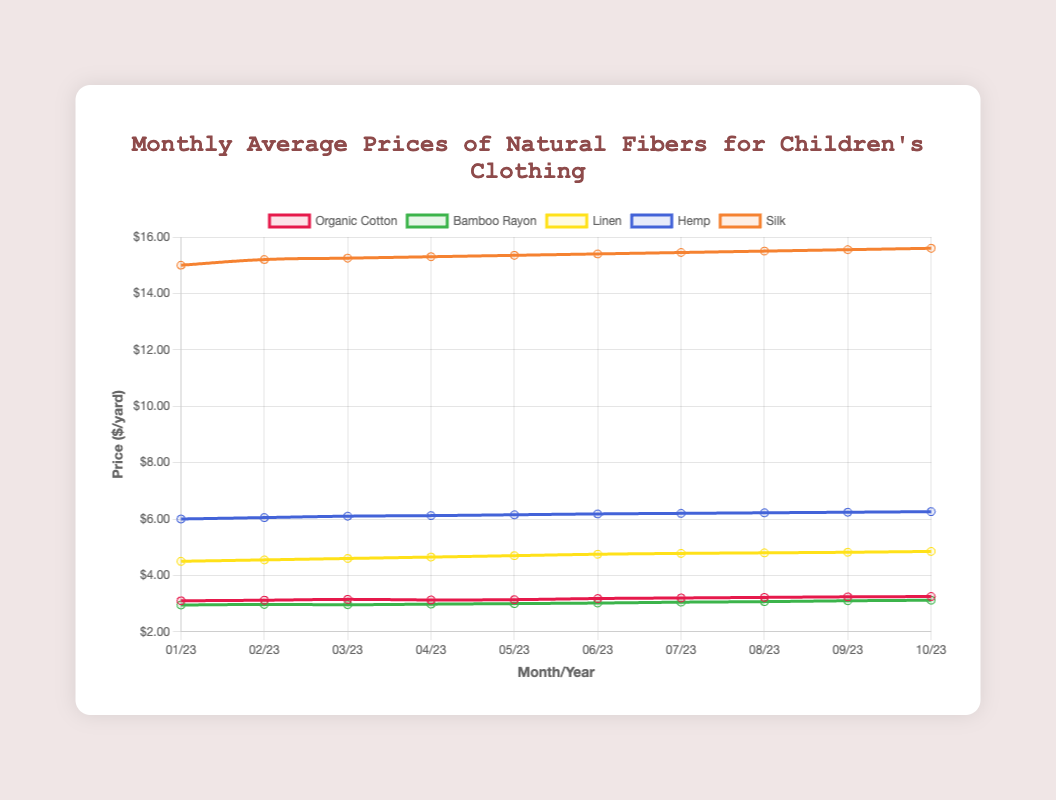What is the trend observed in the prices of Silk from January to October 2023? Examine the line representing Silk on the plot. It starts at a price of $15.00 in January and shows a consistent increase each month, culminating at $15.60 in October. This indicates a steady upward trend.
Answer: Steadily increasing Which fiber had the highest price in October 2023? Locate October 2023 on the x-axis and compare the heights of the lines for all fibers at this point. The line for Silk is the highest, reaching $15.60.
Answer: Silk Between Organic Cotton and Bamboo Rayon, which one had a higher average monthly price over the period January to October 2023? Calculate the average for each by summing their monthly prices and dividing by 10 (the number of months). For Organic Cotton: (3.10 + 3.12 + 3.15 + 3.13 + 3.14 + 3.18 + 3.20 + 3.22 + 3.24 + 3.25)/10 = 3.173. For Bamboo Rayon: (2.95 + 2.97 + 2.96 + 2.98 + 3.00 + 3.02 + 3.05 + 3.07 + 3.10 + 3.12)/10 = 3.022. Organic Cotton has a higher average.
Answer: Organic Cotton Which fiber shows the least variation in price throughout 2023? Examine the difference between the maximum and minimum prices for each fiber. Organic Cotton ranges from $3.10 to $3.25, Bamboo Rayon from $2.95 to $3.12, Linen from $4.50 to $4.85, Hemp from $6.00 to $6.26, and Silk from $15.00 to $15.60. Bamboo Rayon has the smallest price range ($3.12 - $2.95 = $0.17).
Answer: Bamboo Rayon At any point in time, did the price of Linen surpass Hemp? Compare the lines representing Linen and Hemp over the entire period. At no point does the Linen line surpass the Hemp line, meaning Hemp is consistently priced higher than Linen.
Answer: No How much did the price of Hemp increase from January to October 2023? Calculate the difference between the price of Hemp in January ($6.00) and in October ($6.26). The increase is $6.26 - $6.00 = $0.26.
Answer: $0.26 Which fiber's price experienced an increase every single month? Examine each line to see if the price only ever increases from month to month. Silk's price increases consistently from $15.00 in January to $15.60 in October, which is the only fiber that meets this criteria.
Answer: Silk 